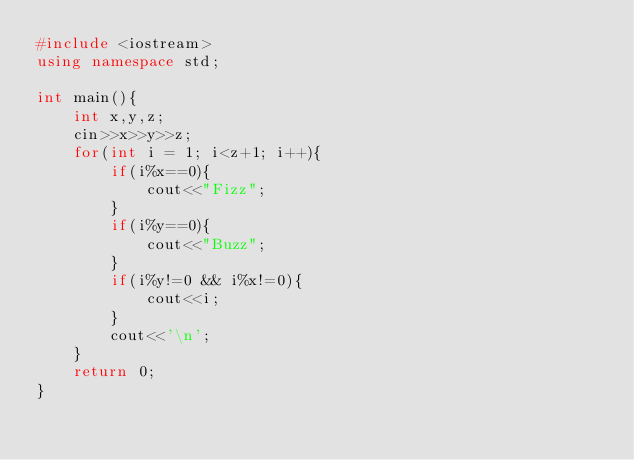Convert code to text. <code><loc_0><loc_0><loc_500><loc_500><_C++_>#include <iostream>
using namespace std;

int main(){
    int x,y,z;
    cin>>x>>y>>z;
    for(int i = 1; i<z+1; i++){
        if(i%x==0){
            cout<<"Fizz";
        }
        if(i%y==0){
            cout<<"Buzz";
        }
        if(i%y!=0 && i%x!=0){
            cout<<i;
        }
        cout<<'\n';
    }
    return 0;
}</code> 